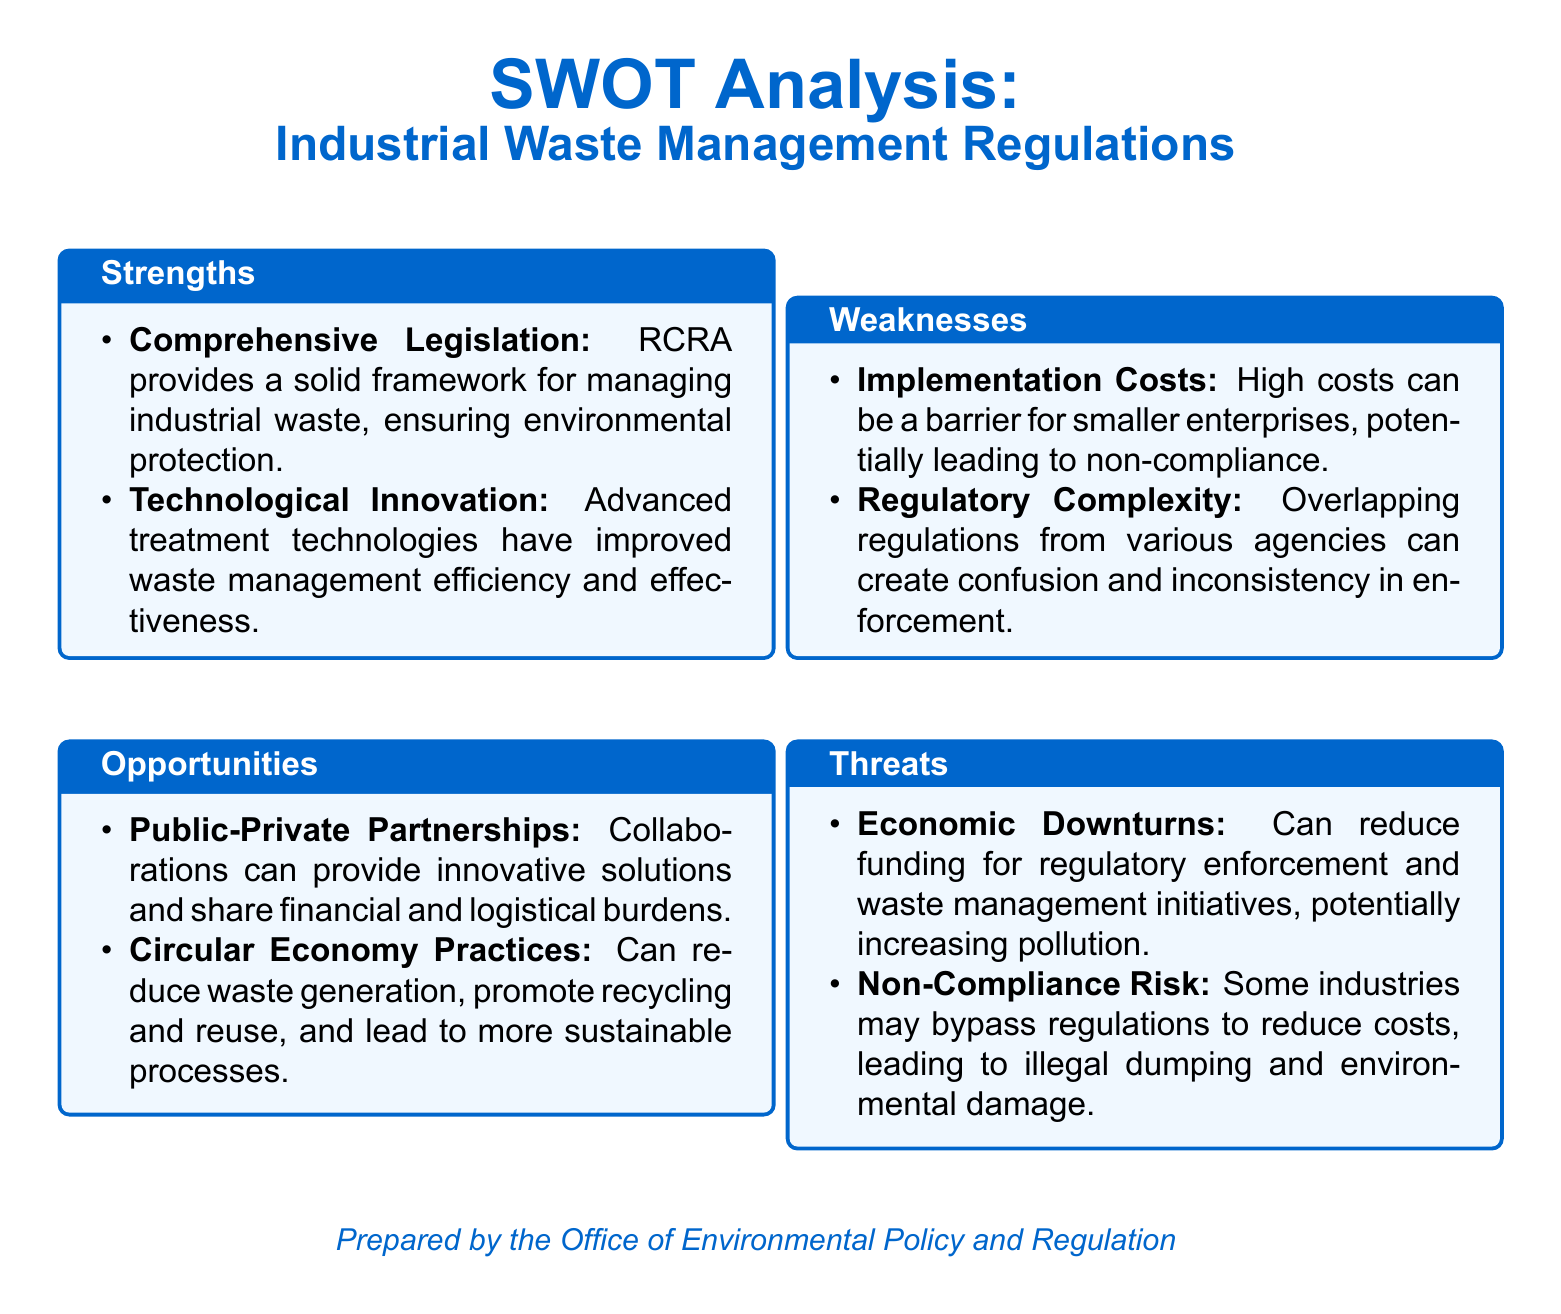what is the title of the document? The title states "SWOT Analysis: Industrial Waste Management Regulations."
Answer: SWOT Analysis: Industrial Waste Management Regulations how many strengths are mentioned? The document lists two strengths under the SWOT analysis section.
Answer: 2 what is one factor contributing to regulatory complexity? The document states that overlapping regulations create confusion.
Answer: Overlapping regulations name one technological advancement mentioned. The document refers to advanced treatment technologies improving waste management.
Answer: Advanced treatment technologies what is a potential opportunity highlighted in the document? The document mentions public-private partnerships as an opportunity.
Answer: Public-Private Partnerships what is one threat associated with economic changes? The document indicates that economic downturns can lead to reduced funding for regulatory enforcement.
Answer: Reduced funding for regulatory enforcement which agency prepared the document? The document specifies that it was prepared by the Office of Environmental Policy and Regulation.
Answer: Office of Environmental Policy and Regulation what is a weakness related to smaller enterprises? The document highlights high implementation costs as a barrier for smaller enterprises.
Answer: High implementation costs 